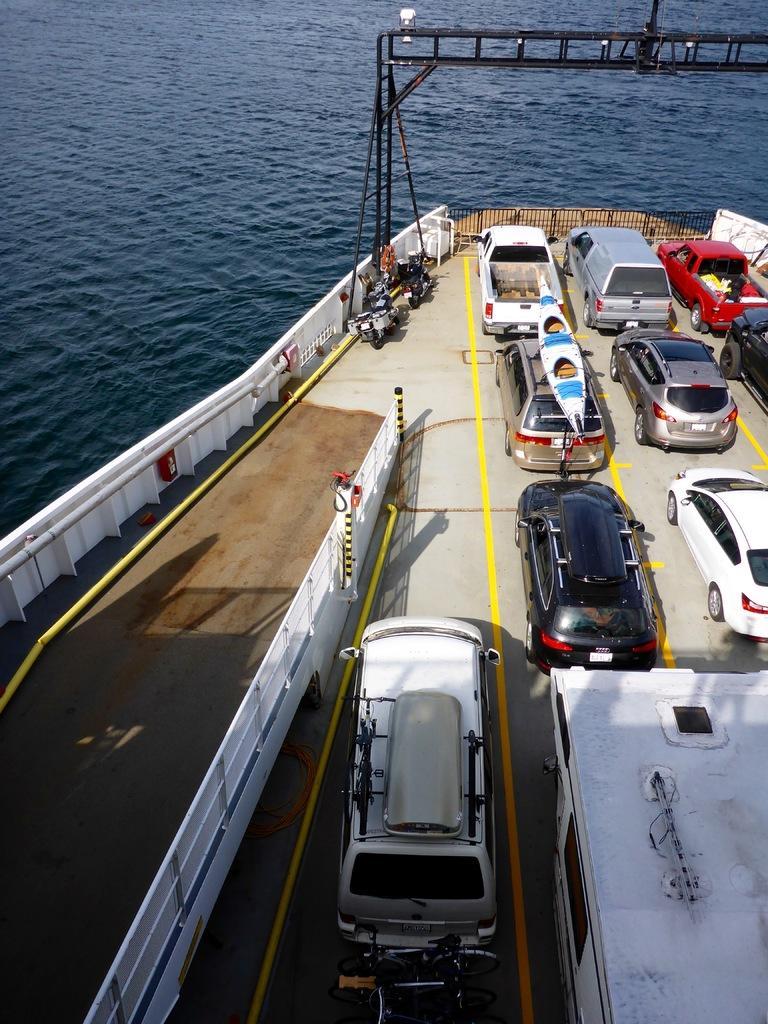Please provide a concise description of this image. In this image I can see few cars in the boat and the boat is on the water, in front the car is in white color. 